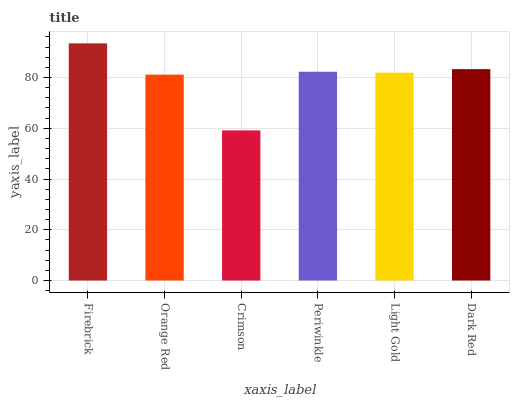Is Orange Red the minimum?
Answer yes or no. No. Is Orange Red the maximum?
Answer yes or no. No. Is Firebrick greater than Orange Red?
Answer yes or no. Yes. Is Orange Red less than Firebrick?
Answer yes or no. Yes. Is Orange Red greater than Firebrick?
Answer yes or no. No. Is Firebrick less than Orange Red?
Answer yes or no. No. Is Periwinkle the high median?
Answer yes or no. Yes. Is Light Gold the low median?
Answer yes or no. Yes. Is Dark Red the high median?
Answer yes or no. No. Is Dark Red the low median?
Answer yes or no. No. 